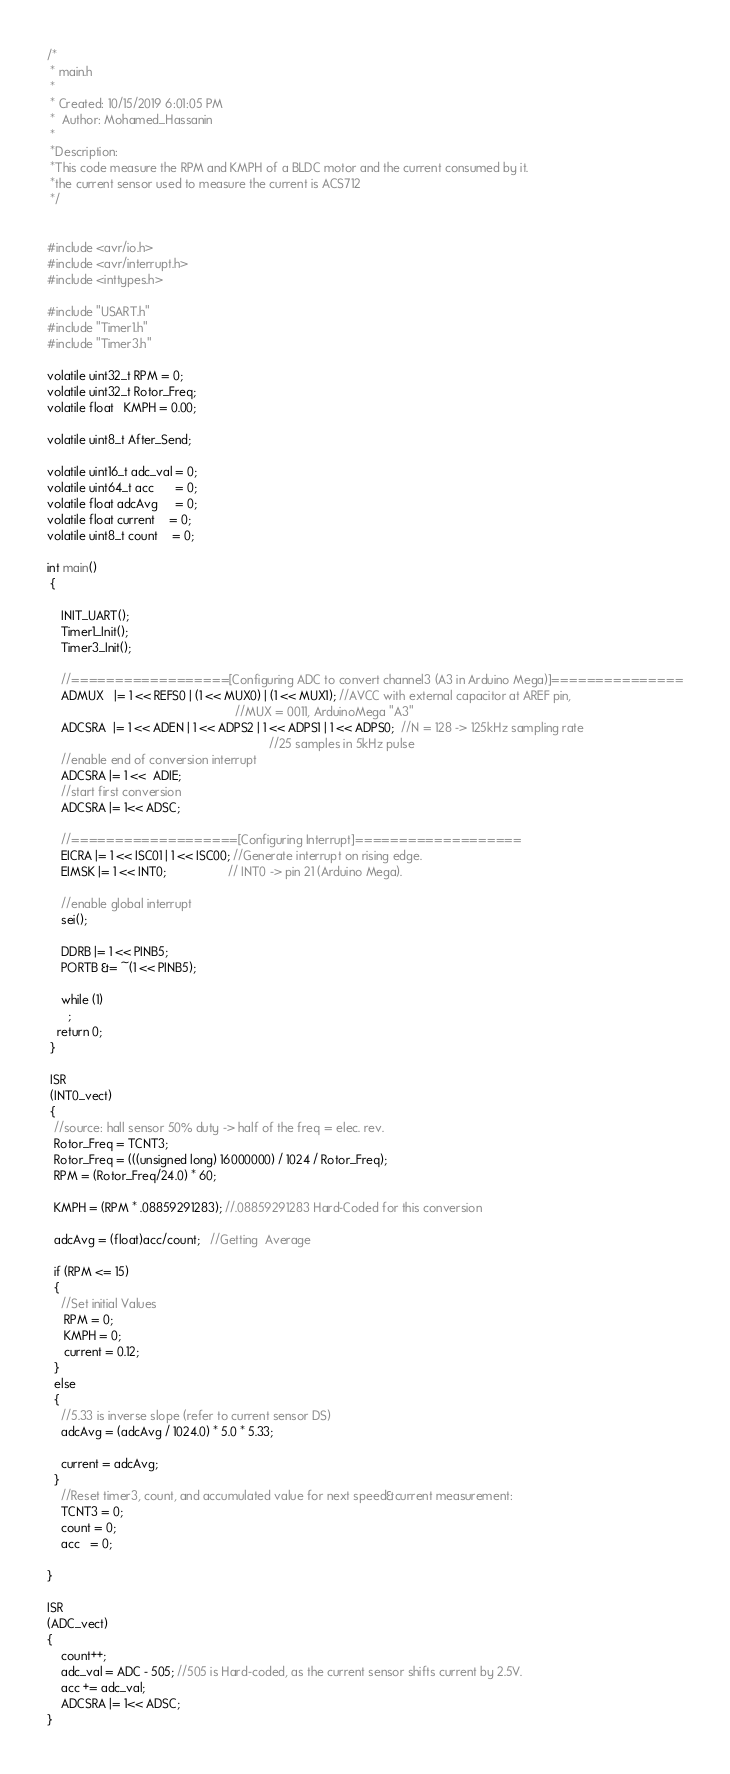<code> <loc_0><loc_0><loc_500><loc_500><_C_>/*
 * main.h
 *
 * Created: 10/15/2019 6:01:05 PM
 *  Author: Mohamed_Hassanin
 *
 *Description:
 *This code measure the RPM and KMPH of a BLDC motor and the current consumed by it.
 *the current sensor used to measure the current is ACS712
 */ 


#include <avr/io.h>
#include <avr/interrupt.h>
#include <inttypes.h>

#include "USART.h"
#include "Timer1.h"
#include "Timer3.h"

volatile uint32_t RPM = 0;
volatile uint32_t Rotor_Freq;
volatile float   KMPH = 0.00; 

volatile uint8_t After_Send;

volatile uint16_t adc_val = 0;
volatile uint64_t acc	  = 0;
volatile float adcAvg     = 0;
volatile float current    = 0;
volatile uint8_t count    = 0;

int main()
 { 
	 
	INIT_UART();
	Timer1_Init();
	Timer3_Init();
	
	//==================[Configuring ADC to convert channel3 (A3 in Arduino Mega)]===============
	ADMUX   |= 1 << REFS0 | (1 << MUX0) | (1 << MUX1); //AVCC with external capacitor at AREF pin,
													   //MUX = 0011, ArduinoMega "A3"
	ADCSRA  |= 1 << ADEN | 1 << ADPS2 | 1 << ADPS1 | 1 << ADPS0;  //N = 128 -> 125kHz sampling rate
																 //25 samples in 5kHz pulse
	//enable end of conversion interrupt
	ADCSRA |= 1 <<  ADIE;
	//start first conversion
	ADCSRA |= 1<< ADSC;
	
	//===================[Configuring Interrupt]===================
	EICRA |= 1 << ISC01 | 1 << ISC00; //Generate interrupt on rising edge.
	EIMSK |= 1 << INT0;				  // INT0 -> pin 21 (Arduino Mega).	 
	
	//enable global interrupt
	sei();
	
	DDRB |= 1 << PINB5;
	PORTB &= ~(1 << PINB5);
		
	while (1)
      ;
   return 0;
 }
 
 ISR
 (INT0_vect)
 {
  //source: hall sensor 50% duty -> half of the freq = elec. rev.
  Rotor_Freq = TCNT3;
  Rotor_Freq = (((unsigned long) 16000000) / 1024 / Rotor_Freq);		 
  RPM = (Rotor_Freq/24.0) * 60;
  
  KMPH = (RPM * .08859291283); //.08859291283 Hard-Coded for this conversion
  
  adcAvg = (float)acc/count;   //Getting  Average
  
  if (RPM <= 15)
  {
	//Set initial Values  
	 RPM = 0;
	 KMPH = 0;  
	 current = 0.12;
  }
  else
  {
    //5.33 is inverse slope (refer to current sensor DS)
    adcAvg = (adcAvg / 1024.0) * 5.0 * 5.33;
     	 
    current = adcAvg;
  }
	//Reset timer3, count, and accumulated value for next speed&current measurement:
	TCNT3 = 0;
	count = 0;
	acc   = 0;
	
}

ISR
(ADC_vect)
{
	count++;
	adc_val = ADC - 505; //505 is Hard-coded, as the current sensor shifts current by 2.5V.
	acc += adc_val;
	ADCSRA |= 1<< ADSC;
}
</code> 